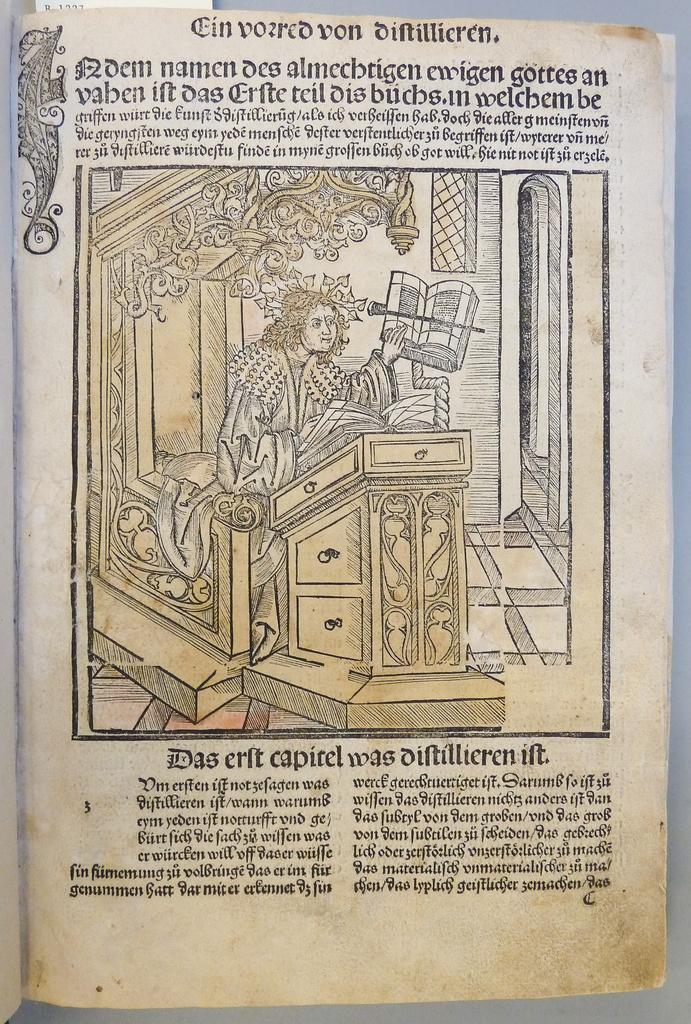Could you give a brief overview of what you see in this image? In this picture there is an image of a person sitting and there are some other objects in front and beside him and there is something written above and below the image. 